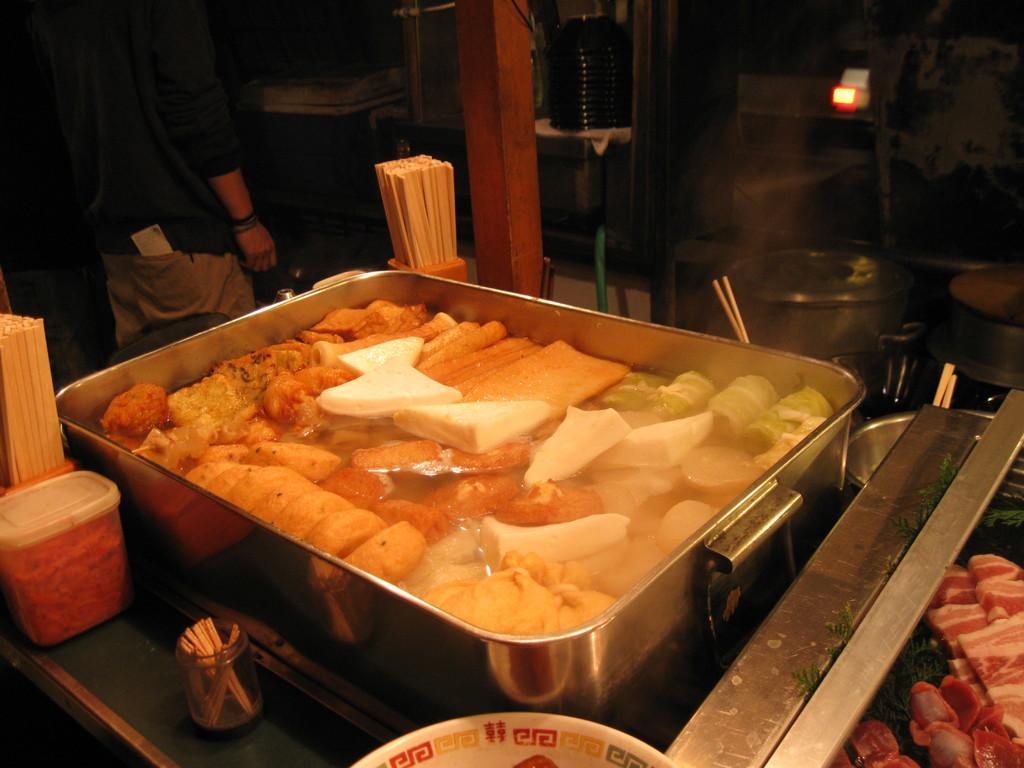In one or two sentences, can you explain what this image depicts? In this picture we can see a steel bowl in the front, there is some food and water present in the bowl, on the left side there is a box and chopsticks, in the background there is a person standing, on the right side we can see some food and bowls, there is a dark background. 